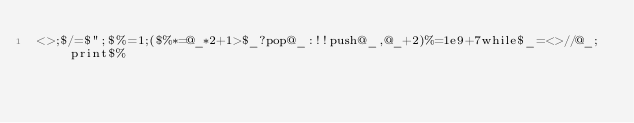Convert code to text. <code><loc_0><loc_0><loc_500><loc_500><_Perl_><>;$/=$";$%=1;($%*=@_*2+1>$_?pop@_:!!push@_,@_+2)%=1e9+7while$_=<>//@_;print$%</code> 